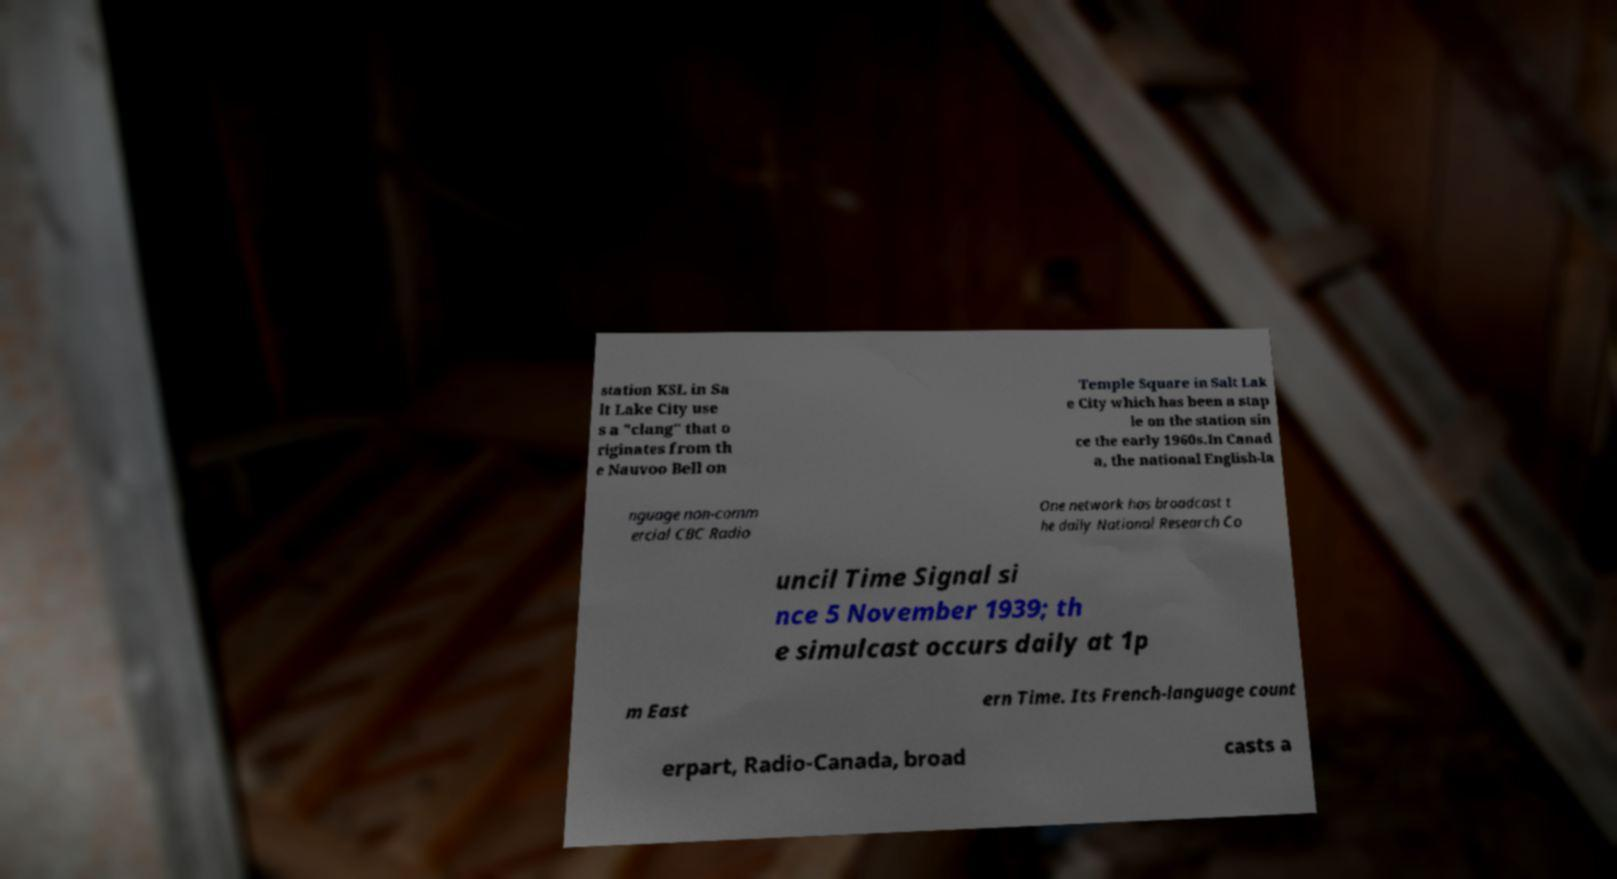Can you accurately transcribe the text from the provided image for me? station KSL in Sa lt Lake City use s a "clang" that o riginates from th e Nauvoo Bell on Temple Square in Salt Lak e City which has been a stap le on the station sin ce the early 1960s.In Canad a, the national English-la nguage non-comm ercial CBC Radio One network has broadcast t he daily National Research Co uncil Time Signal si nce 5 November 1939; th e simulcast occurs daily at 1p m East ern Time. Its French-language count erpart, Radio-Canada, broad casts a 